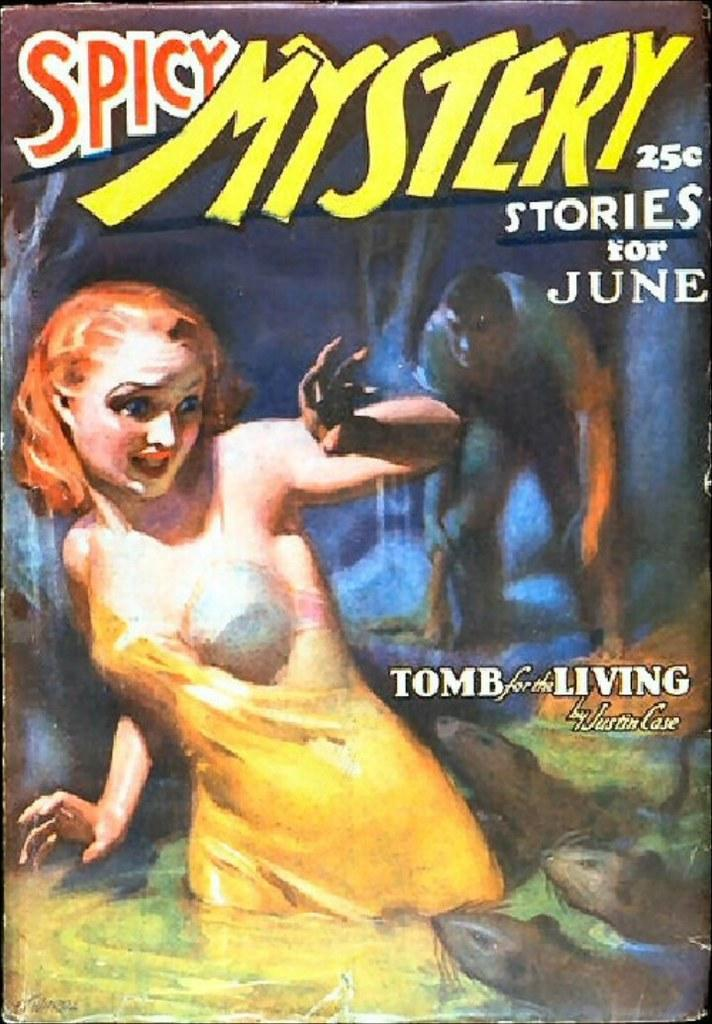What is featured on the poster in the image? The poster contains pictures of people and animals. Is there any text on the poster? Yes, there is text on the poster. What type of sponge is being used to clean the pocket in the image? There is no sponge or pocket present in the image. 